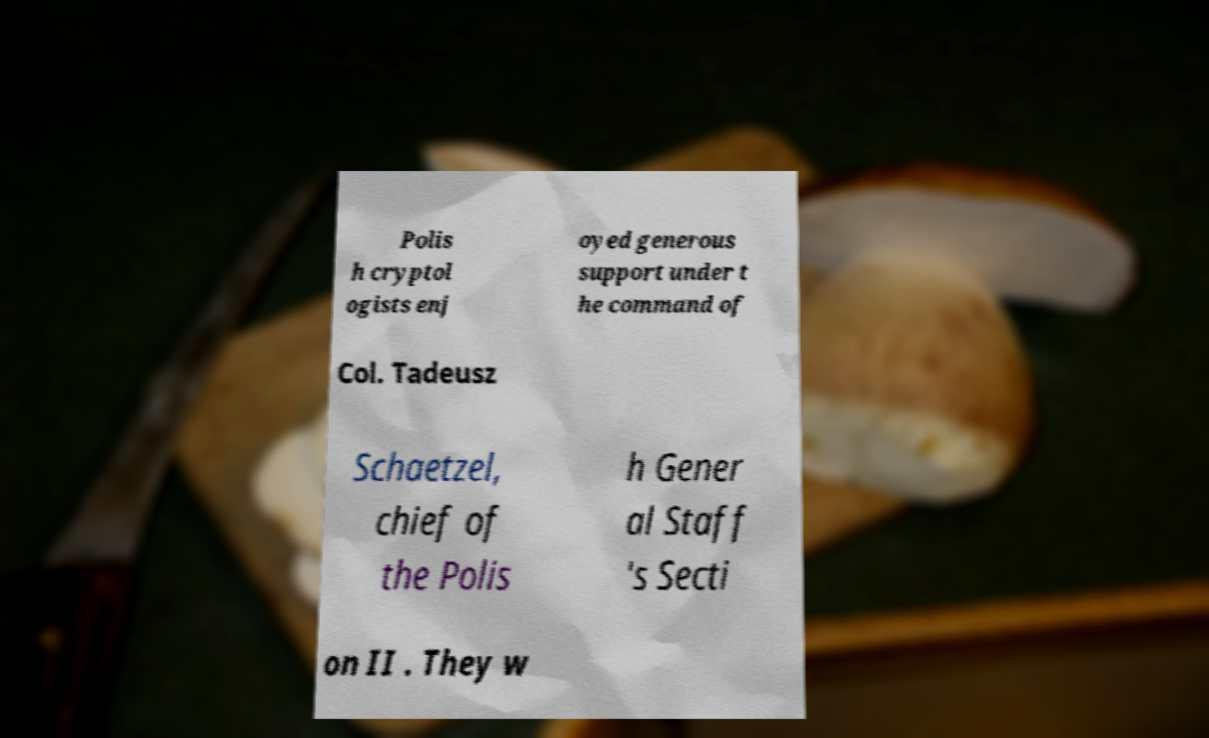Can you accurately transcribe the text from the provided image for me? Polis h cryptol ogists enj oyed generous support under t he command of Col. Tadeusz Schaetzel, chief of the Polis h Gener al Staff 's Secti on II . They w 